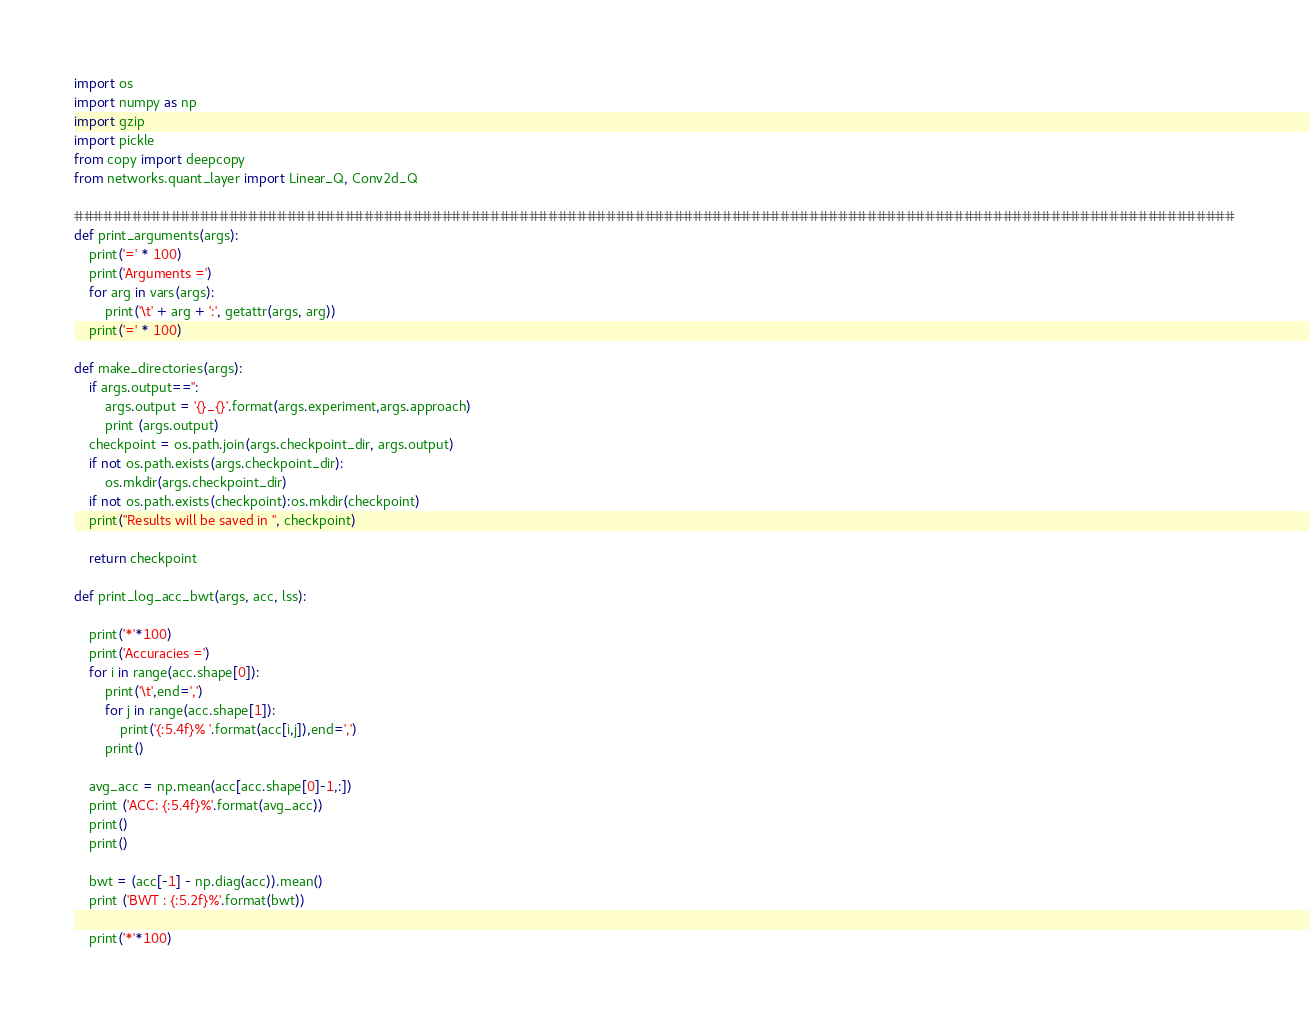<code> <loc_0><loc_0><loc_500><loc_500><_Python_>import os
import numpy as np
import gzip
import pickle
from copy import deepcopy
from networks.quant_layer import Linear_Q, Conv2d_Q

########################################################################################################################
def print_arguments(args):
    print('=' * 100)
    print('Arguments =')
    for arg in vars(args):
        print('\t' + arg + ':', getattr(args, arg))
    print('=' * 100)

def make_directories(args):
    if args.output=='':
        args.output = '{}_{}'.format(args.experiment,args.approach)
        print (args.output)
    checkpoint = os.path.join(args.checkpoint_dir, args.output)
    if not os.path.exists(args.checkpoint_dir):
        os.mkdir(args.checkpoint_dir)
    if not os.path.exists(checkpoint):os.mkdir(checkpoint)
    print("Results will be saved in ", checkpoint)

    return checkpoint

def print_log_acc_bwt(args, acc, lss):

    print('*'*100)
    print('Accuracies =')
    for i in range(acc.shape[0]):
        print('\t',end=',')
        for j in range(acc.shape[1]):
            print('{:5.4f}% '.format(acc[i,j]),end=',')
        print()

    avg_acc = np.mean(acc[acc.shape[0]-1,:])
    print ('ACC: {:5.4f}%'.format(avg_acc))
    print()
    print()

    bwt = (acc[-1] - np.diag(acc)).mean()
    print ('BWT : {:5.2f}%'.format(bwt))

    print('*'*100)</code> 